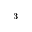Convert formula to latex. <formula><loc_0><loc_0><loc_500><loc_500>^ { - 3 }</formula> 